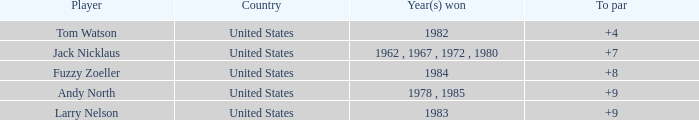Could you help me parse every detail presented in this table? {'header': ['Player', 'Country', 'Year(s) won', 'To par'], 'rows': [['Tom Watson', 'United States', '1982', '+4'], ['Jack Nicklaus', 'United States', '1962 , 1967 , 1972 , 1980', '+7'], ['Fuzzy Zoeller', 'United States', '1984', '+8'], ['Andy North', 'United States', '1978 , 1985', '+9'], ['Larry Nelson', 'United States', '1983', '+9']]} In 1984, which country did the player with a total score below 153 come from? United States. 